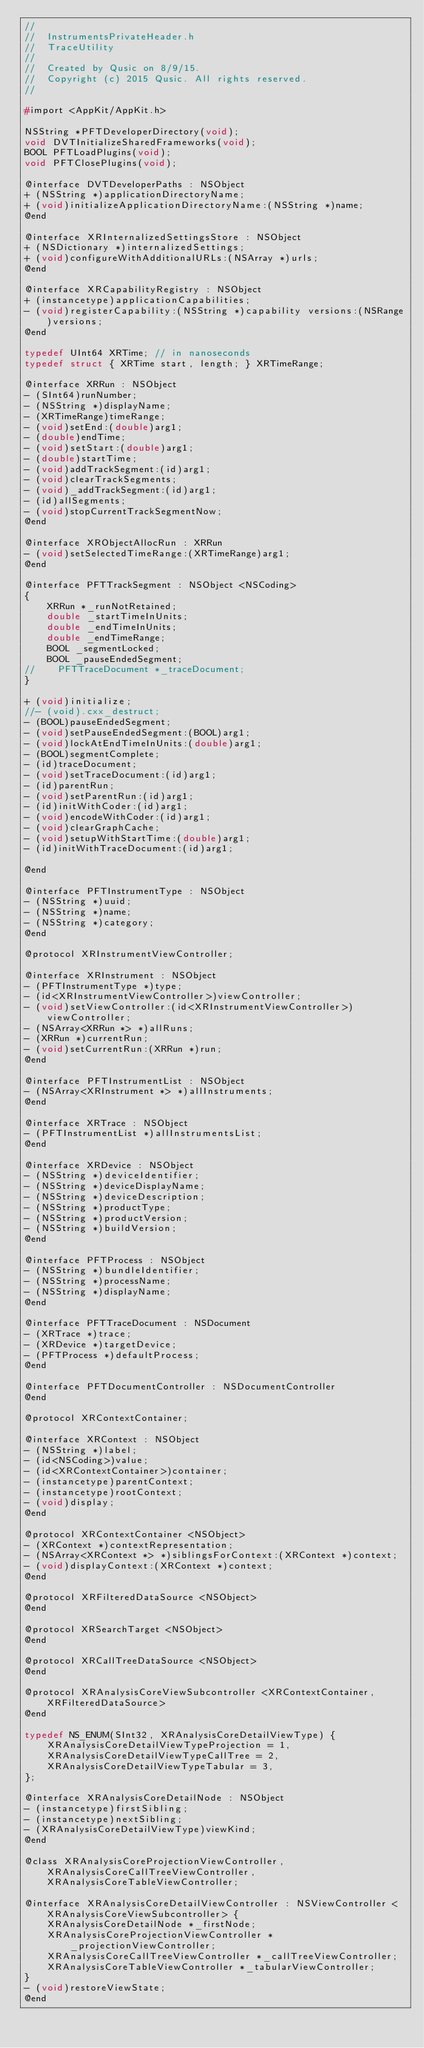<code> <loc_0><loc_0><loc_500><loc_500><_C_>//
//  InstrumentsPrivateHeader.h
//  TraceUtility
//
//  Created by Qusic on 8/9/15.
//  Copyright (c) 2015 Qusic. All rights reserved.
//

#import <AppKit/AppKit.h>

NSString *PFTDeveloperDirectory(void);
void DVTInitializeSharedFrameworks(void);
BOOL PFTLoadPlugins(void);
void PFTClosePlugins(void);

@interface DVTDeveloperPaths : NSObject
+ (NSString *)applicationDirectoryName;
+ (void)initializeApplicationDirectoryName:(NSString *)name;
@end

@interface XRInternalizedSettingsStore : NSObject
+ (NSDictionary *)internalizedSettings;
+ (void)configureWithAdditionalURLs:(NSArray *)urls;
@end

@interface XRCapabilityRegistry : NSObject
+ (instancetype)applicationCapabilities;
- (void)registerCapability:(NSString *)capability versions:(NSRange)versions;
@end

typedef UInt64 XRTime; // in nanoseconds
typedef struct { XRTime start, length; } XRTimeRange;

@interface XRRun : NSObject
- (SInt64)runNumber;
- (NSString *)displayName;
- (XRTimeRange)timeRange;
- (void)setEnd:(double)arg1;
- (double)endTime;
- (void)setStart:(double)arg1;
- (double)startTime;
- (void)addTrackSegment:(id)arg1;
- (void)clearTrackSegments;
- (void)_addTrackSegment:(id)arg1;
- (id)allSegments;
- (void)stopCurrentTrackSegmentNow;
@end

@interface XRObjectAllocRun : XRRun
- (void)setSelectedTimeRange:(XRTimeRange)arg1;
@end

@interface PFTTrackSegment : NSObject <NSCoding>
{
    XRRun *_runNotRetained;
    double _startTimeInUnits;
    double _endTimeInUnits;
    double _endTimeRange;
    BOOL _segmentLocked;
    BOOL _pauseEndedSegment;
//    PFTTraceDocument *_traceDocument;
}

+ (void)initialize;
//- (void).cxx_destruct;
- (BOOL)pauseEndedSegment;
- (void)setPauseEndedSegment:(BOOL)arg1;
- (void)lockAtEndTimeInUnits:(double)arg1;
- (BOOL)segmentComplete;
- (id)traceDocument;
- (void)setTraceDocument:(id)arg1;
- (id)parentRun;
- (void)setParentRun:(id)arg1;
- (id)initWithCoder:(id)arg1;
- (void)encodeWithCoder:(id)arg1;
- (void)clearGraphCache;
- (void)setupWithStartTime:(double)arg1;
- (id)initWithTraceDocument:(id)arg1;

@end

@interface PFTInstrumentType : NSObject
- (NSString *)uuid;
- (NSString *)name;
- (NSString *)category;
@end

@protocol XRInstrumentViewController;

@interface XRInstrument : NSObject
- (PFTInstrumentType *)type;
- (id<XRInstrumentViewController>)viewController;
- (void)setViewController:(id<XRInstrumentViewController>)viewController;
- (NSArray<XRRun *> *)allRuns;
- (XRRun *)currentRun;
- (void)setCurrentRun:(XRRun *)run;
@end

@interface PFTInstrumentList : NSObject
- (NSArray<XRInstrument *> *)allInstruments;
@end

@interface XRTrace : NSObject
- (PFTInstrumentList *)allInstrumentsList;
@end

@interface XRDevice : NSObject
- (NSString *)deviceIdentifier;
- (NSString *)deviceDisplayName;
- (NSString *)deviceDescription;
- (NSString *)productType;
- (NSString *)productVersion;
- (NSString *)buildVersion;
@end

@interface PFTProcess : NSObject
- (NSString *)bundleIdentifier;
- (NSString *)processName;
- (NSString *)displayName;
@end

@interface PFTTraceDocument : NSDocument
- (XRTrace *)trace;
- (XRDevice *)targetDevice;
- (PFTProcess *)defaultProcess;
@end

@interface PFTDocumentController : NSDocumentController
@end

@protocol XRContextContainer;

@interface XRContext : NSObject
- (NSString *)label;
- (id<NSCoding>)value;
- (id<XRContextContainer>)container;
- (instancetype)parentContext;
- (instancetype)rootContext;
- (void)display;
@end

@protocol XRContextContainer <NSObject>
- (XRContext *)contextRepresentation;
- (NSArray<XRContext *> *)siblingsForContext:(XRContext *)context;
- (void)displayContext:(XRContext *)context;
@end

@protocol XRFilteredDataSource <NSObject>
@end

@protocol XRSearchTarget <NSObject>
@end

@protocol XRCallTreeDataSource <NSObject>
@end

@protocol XRAnalysisCoreViewSubcontroller <XRContextContainer, XRFilteredDataSource>
@end

typedef NS_ENUM(SInt32, XRAnalysisCoreDetailViewType) {
    XRAnalysisCoreDetailViewTypeProjection = 1,
    XRAnalysisCoreDetailViewTypeCallTree = 2,
    XRAnalysisCoreDetailViewTypeTabular = 3,
};

@interface XRAnalysisCoreDetailNode : NSObject
- (instancetype)firstSibling;
- (instancetype)nextSibling;
- (XRAnalysisCoreDetailViewType)viewKind;
@end

@class XRAnalysisCoreProjectionViewController, XRAnalysisCoreCallTreeViewController, XRAnalysisCoreTableViewController;

@interface XRAnalysisCoreDetailViewController : NSViewController <XRAnalysisCoreViewSubcontroller> {
    XRAnalysisCoreDetailNode *_firstNode;
    XRAnalysisCoreProjectionViewController *_projectionViewController;
    XRAnalysisCoreCallTreeViewController *_callTreeViewController;
    XRAnalysisCoreTableViewController *_tabularViewController;
}
- (void)restoreViewState;
@end
</code> 